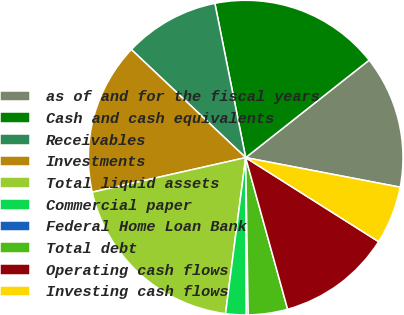Convert chart. <chart><loc_0><loc_0><loc_500><loc_500><pie_chart><fcel>as of and for the fiscal years<fcel>Cash and cash equivalents<fcel>Receivables<fcel>Investments<fcel>Total liquid assets<fcel>Commercial paper<fcel>Federal Home Loan Bank<fcel>Total debt<fcel>Operating cash flows<fcel>Investing cash flows<nl><fcel>13.65%<fcel>17.5%<fcel>9.81%<fcel>15.58%<fcel>19.43%<fcel>2.11%<fcel>0.19%<fcel>4.04%<fcel>11.73%<fcel>5.96%<nl></chart> 